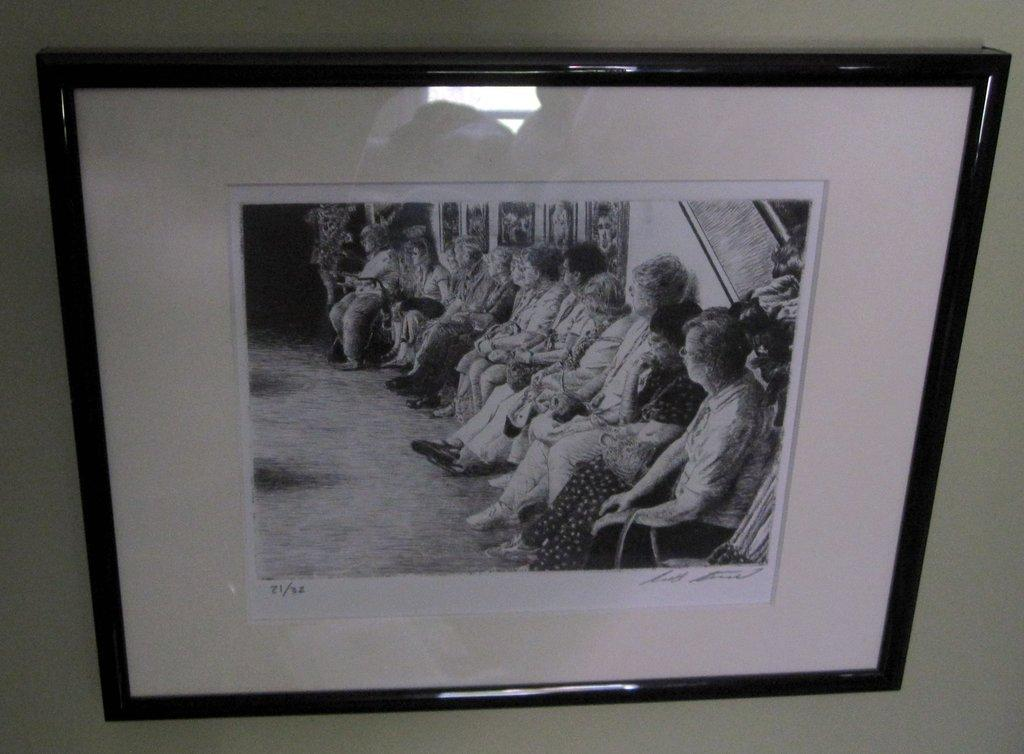<image>
Relay a brief, clear account of the picture shown. A framed picture that is number 21 out of a series of 32. 